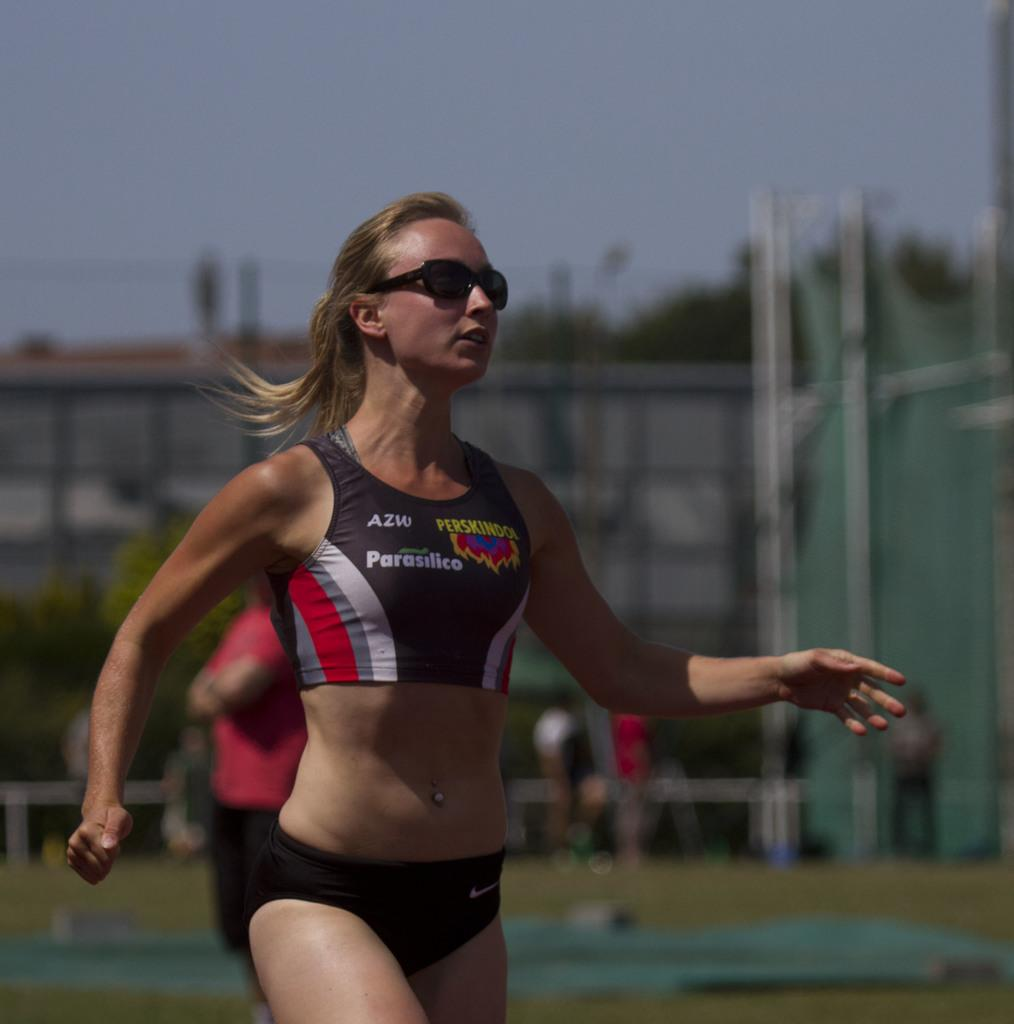<image>
Offer a succinct explanation of the picture presented. a woman in sportswear branded with parasilico and azw 